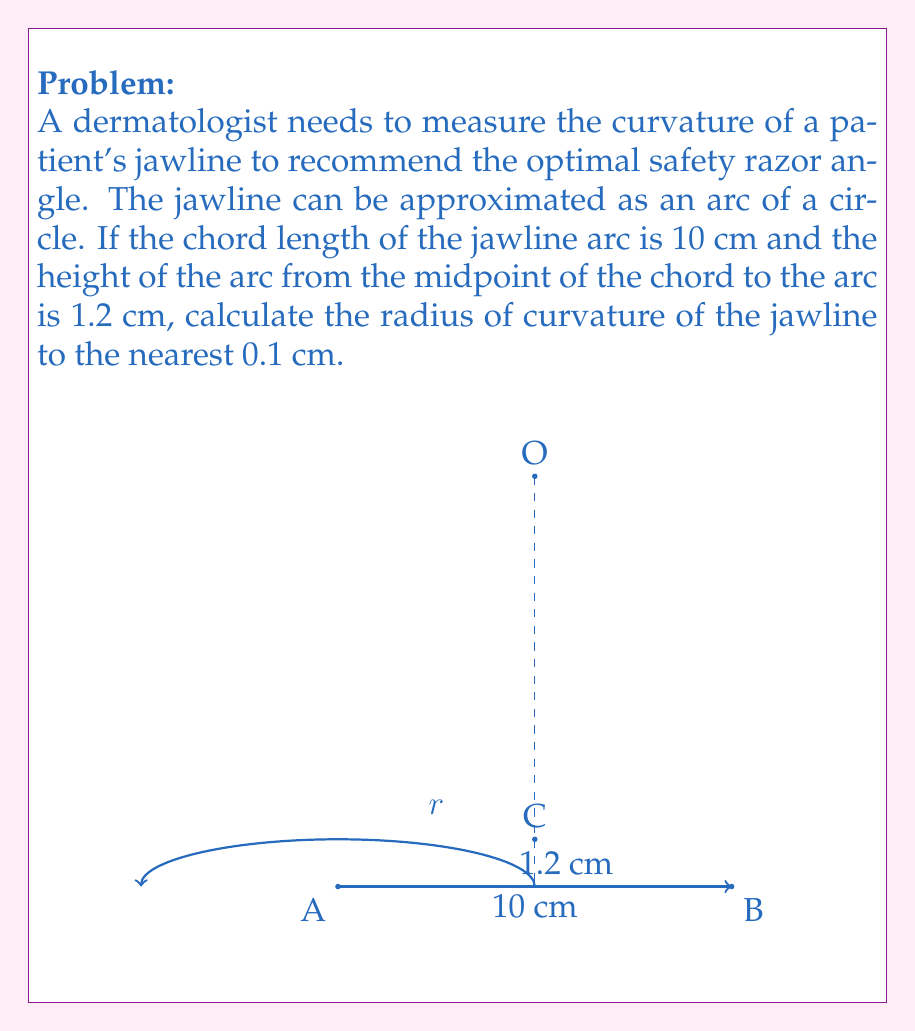Can you answer this question? To find the radius of curvature, we can use the formula for the radius of a circular segment:

$$ r = \frac{h}{2} + \frac{c^2}{8h} $$

Where:
$r$ = radius of curvature
$h$ = height of the arc
$c$ = chord length

Given:
$h = 1.2$ cm
$c = 10$ cm

Step 1: Substitute the values into the formula:

$$ r = \frac{1.2}{2} + \frac{10^2}{8(1.2)} $$

Step 2: Simplify:

$$ r = 0.6 + \frac{100}{9.6} $$

Step 3: Calculate:

$$ r = 0.6 + 10.4166... $$

$$ r = 11.0166... $$

Step 4: Round to the nearest 0.1 cm:

$$ r \approx 11.0 \text{ cm} $$

This radius of curvature can help the dermatologist determine the optimal angle for the safety razor to follow the contour of the patient's jawline, ensuring a close and safe shave for sensitive skin.
Answer: 11.0 cm 